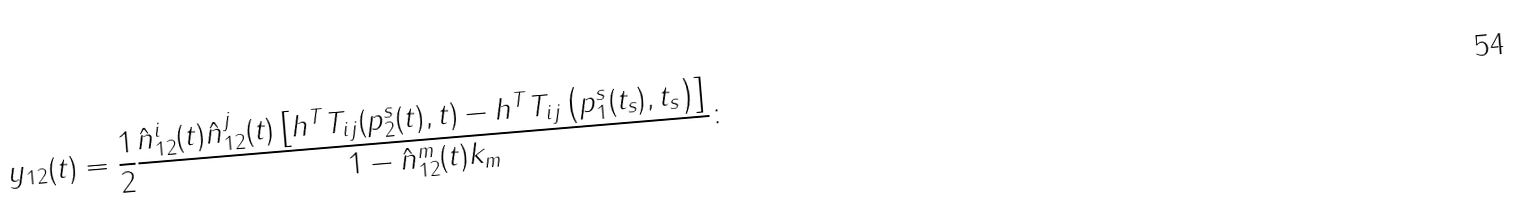Convert formula to latex. <formula><loc_0><loc_0><loc_500><loc_500>y _ { 1 2 } ( t ) = \frac { 1 } { 2 } \frac { \hat { n } ^ { i } _ { 1 2 } ( t ) \hat { n } ^ { j } _ { 1 2 } ( t ) \left [ h ^ { T } T _ { i j } ( p ^ { s } _ { 2 } ( t ) , t ) - h ^ { T } T _ { i j } \left ( p ^ { s } _ { 1 } ( t _ { s } ) , t _ { s } \right ) \right ] } { 1 - \hat { n } ^ { m } _ { 1 2 } ( t ) k _ { m } } \colon</formula> 